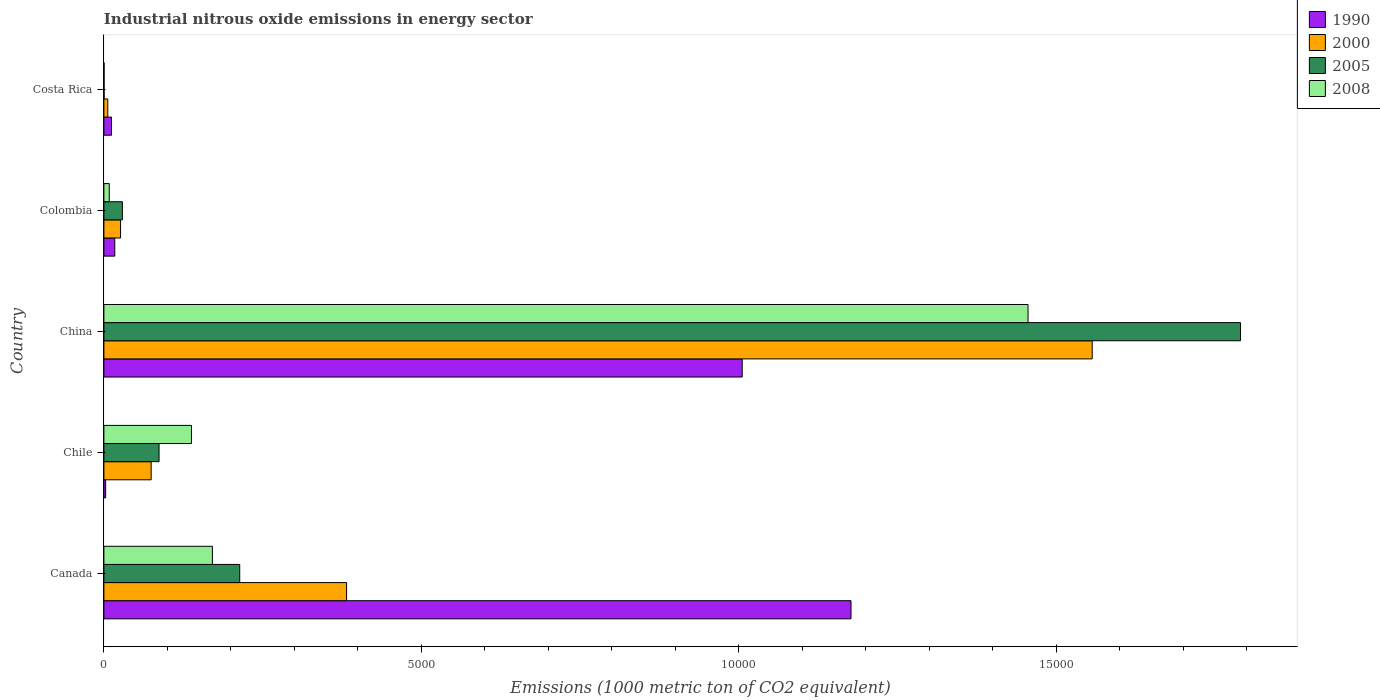How many groups of bars are there?
Make the answer very short. 5. Are the number of bars per tick equal to the number of legend labels?
Keep it short and to the point. Yes. Are the number of bars on each tick of the Y-axis equal?
Provide a succinct answer. Yes. How many bars are there on the 1st tick from the bottom?
Your response must be concise. 4. What is the label of the 3rd group of bars from the top?
Your answer should be compact. China. What is the amount of industrial nitrous oxide emitted in 2000 in Canada?
Ensure brevity in your answer.  3823.3. Across all countries, what is the maximum amount of industrial nitrous oxide emitted in 2008?
Offer a terse response. 1.46e+04. Across all countries, what is the minimum amount of industrial nitrous oxide emitted in 1990?
Provide a short and direct response. 27.9. What is the total amount of industrial nitrous oxide emitted in 2008 in the graph?
Your answer should be compact. 1.77e+04. What is the difference between the amount of industrial nitrous oxide emitted in 2008 in China and that in Costa Rica?
Your answer should be very brief. 1.46e+04. What is the difference between the amount of industrial nitrous oxide emitted in 2000 in Chile and the amount of industrial nitrous oxide emitted in 2005 in Canada?
Your answer should be compact. -1394.8. What is the average amount of industrial nitrous oxide emitted in 1990 per country?
Your answer should be very brief. 4429.12. What is the difference between the amount of industrial nitrous oxide emitted in 2000 and amount of industrial nitrous oxide emitted in 2008 in China?
Offer a very short reply. 1010.8. In how many countries, is the amount of industrial nitrous oxide emitted in 2005 greater than 3000 1000 metric ton?
Make the answer very short. 1. What is the ratio of the amount of industrial nitrous oxide emitted in 1990 in Canada to that in Costa Rica?
Give a very brief answer. 98.08. Is the amount of industrial nitrous oxide emitted in 2000 in Canada less than that in China?
Provide a succinct answer. Yes. Is the difference between the amount of industrial nitrous oxide emitted in 2000 in China and Colombia greater than the difference between the amount of industrial nitrous oxide emitted in 2008 in China and Colombia?
Offer a terse response. Yes. What is the difference between the highest and the second highest amount of industrial nitrous oxide emitted in 2005?
Offer a terse response. 1.58e+04. What is the difference between the highest and the lowest amount of industrial nitrous oxide emitted in 2008?
Keep it short and to the point. 1.46e+04. In how many countries, is the amount of industrial nitrous oxide emitted in 1990 greater than the average amount of industrial nitrous oxide emitted in 1990 taken over all countries?
Your response must be concise. 2. Is the sum of the amount of industrial nitrous oxide emitted in 2005 in Canada and China greater than the maximum amount of industrial nitrous oxide emitted in 2008 across all countries?
Ensure brevity in your answer.  Yes. Is it the case that in every country, the sum of the amount of industrial nitrous oxide emitted in 2005 and amount of industrial nitrous oxide emitted in 2008 is greater than the sum of amount of industrial nitrous oxide emitted in 1990 and amount of industrial nitrous oxide emitted in 2000?
Your answer should be very brief. No. What does the 4th bar from the top in Colombia represents?
Offer a very short reply. 1990. Is it the case that in every country, the sum of the amount of industrial nitrous oxide emitted in 2008 and amount of industrial nitrous oxide emitted in 1990 is greater than the amount of industrial nitrous oxide emitted in 2005?
Ensure brevity in your answer.  No. How many bars are there?
Provide a short and direct response. 20. How many countries are there in the graph?
Your answer should be very brief. 5. Are the values on the major ticks of X-axis written in scientific E-notation?
Your answer should be very brief. No. Does the graph contain any zero values?
Provide a succinct answer. No. Does the graph contain grids?
Provide a succinct answer. No. Where does the legend appear in the graph?
Provide a short and direct response. Top right. How many legend labels are there?
Provide a short and direct response. 4. How are the legend labels stacked?
Provide a short and direct response. Vertical. What is the title of the graph?
Provide a succinct answer. Industrial nitrous oxide emissions in energy sector. Does "1986" appear as one of the legend labels in the graph?
Your answer should be very brief. No. What is the label or title of the X-axis?
Your answer should be very brief. Emissions (1000 metric ton of CO2 equivalent). What is the Emissions (1000 metric ton of CO2 equivalent) in 1990 in Canada?
Your answer should be compact. 1.18e+04. What is the Emissions (1000 metric ton of CO2 equivalent) in 2000 in Canada?
Provide a short and direct response. 3823.3. What is the Emissions (1000 metric ton of CO2 equivalent) of 2005 in Canada?
Your response must be concise. 2139.7. What is the Emissions (1000 metric ton of CO2 equivalent) of 2008 in Canada?
Keep it short and to the point. 1709.6. What is the Emissions (1000 metric ton of CO2 equivalent) in 1990 in Chile?
Offer a terse response. 27.9. What is the Emissions (1000 metric ton of CO2 equivalent) of 2000 in Chile?
Offer a terse response. 744.9. What is the Emissions (1000 metric ton of CO2 equivalent) of 2005 in Chile?
Offer a very short reply. 868.8. What is the Emissions (1000 metric ton of CO2 equivalent) in 2008 in Chile?
Ensure brevity in your answer.  1379.7. What is the Emissions (1000 metric ton of CO2 equivalent) in 1990 in China?
Your answer should be compact. 1.01e+04. What is the Emissions (1000 metric ton of CO2 equivalent) in 2000 in China?
Offer a terse response. 1.56e+04. What is the Emissions (1000 metric ton of CO2 equivalent) in 2005 in China?
Offer a terse response. 1.79e+04. What is the Emissions (1000 metric ton of CO2 equivalent) of 2008 in China?
Offer a very short reply. 1.46e+04. What is the Emissions (1000 metric ton of CO2 equivalent) of 1990 in Colombia?
Ensure brevity in your answer.  171.6. What is the Emissions (1000 metric ton of CO2 equivalent) of 2000 in Colombia?
Provide a short and direct response. 262.3. What is the Emissions (1000 metric ton of CO2 equivalent) in 2005 in Colombia?
Ensure brevity in your answer.  291.3. What is the Emissions (1000 metric ton of CO2 equivalent) of 2008 in Colombia?
Ensure brevity in your answer.  84.7. What is the Emissions (1000 metric ton of CO2 equivalent) in 1990 in Costa Rica?
Ensure brevity in your answer.  120. What is the Emissions (1000 metric ton of CO2 equivalent) of 2000 in Costa Rica?
Offer a terse response. 61.4. What is the Emissions (1000 metric ton of CO2 equivalent) in 2008 in Costa Rica?
Provide a succinct answer. 3.1. Across all countries, what is the maximum Emissions (1000 metric ton of CO2 equivalent) in 1990?
Your answer should be compact. 1.18e+04. Across all countries, what is the maximum Emissions (1000 metric ton of CO2 equivalent) in 2000?
Provide a succinct answer. 1.56e+04. Across all countries, what is the maximum Emissions (1000 metric ton of CO2 equivalent) in 2005?
Offer a very short reply. 1.79e+04. Across all countries, what is the maximum Emissions (1000 metric ton of CO2 equivalent) of 2008?
Your answer should be compact. 1.46e+04. Across all countries, what is the minimum Emissions (1000 metric ton of CO2 equivalent) in 1990?
Ensure brevity in your answer.  27.9. Across all countries, what is the minimum Emissions (1000 metric ton of CO2 equivalent) of 2000?
Keep it short and to the point. 61.4. What is the total Emissions (1000 metric ton of CO2 equivalent) of 1990 in the graph?
Keep it short and to the point. 2.21e+04. What is the total Emissions (1000 metric ton of CO2 equivalent) of 2000 in the graph?
Offer a very short reply. 2.05e+04. What is the total Emissions (1000 metric ton of CO2 equivalent) of 2005 in the graph?
Your response must be concise. 2.12e+04. What is the total Emissions (1000 metric ton of CO2 equivalent) in 2008 in the graph?
Your response must be concise. 1.77e+04. What is the difference between the Emissions (1000 metric ton of CO2 equivalent) in 1990 in Canada and that in Chile?
Offer a terse response. 1.17e+04. What is the difference between the Emissions (1000 metric ton of CO2 equivalent) of 2000 in Canada and that in Chile?
Make the answer very short. 3078.4. What is the difference between the Emissions (1000 metric ton of CO2 equivalent) in 2005 in Canada and that in Chile?
Provide a succinct answer. 1270.9. What is the difference between the Emissions (1000 metric ton of CO2 equivalent) of 2008 in Canada and that in Chile?
Offer a very short reply. 329.9. What is the difference between the Emissions (1000 metric ton of CO2 equivalent) of 1990 in Canada and that in China?
Offer a terse response. 1713.9. What is the difference between the Emissions (1000 metric ton of CO2 equivalent) in 2000 in Canada and that in China?
Ensure brevity in your answer.  -1.17e+04. What is the difference between the Emissions (1000 metric ton of CO2 equivalent) of 2005 in Canada and that in China?
Make the answer very short. -1.58e+04. What is the difference between the Emissions (1000 metric ton of CO2 equivalent) of 2008 in Canada and that in China?
Your answer should be very brief. -1.28e+04. What is the difference between the Emissions (1000 metric ton of CO2 equivalent) in 1990 in Canada and that in Colombia?
Provide a short and direct response. 1.16e+04. What is the difference between the Emissions (1000 metric ton of CO2 equivalent) of 2000 in Canada and that in Colombia?
Ensure brevity in your answer.  3561. What is the difference between the Emissions (1000 metric ton of CO2 equivalent) in 2005 in Canada and that in Colombia?
Give a very brief answer. 1848.4. What is the difference between the Emissions (1000 metric ton of CO2 equivalent) in 2008 in Canada and that in Colombia?
Keep it short and to the point. 1624.9. What is the difference between the Emissions (1000 metric ton of CO2 equivalent) of 1990 in Canada and that in Costa Rica?
Provide a short and direct response. 1.16e+04. What is the difference between the Emissions (1000 metric ton of CO2 equivalent) of 2000 in Canada and that in Costa Rica?
Ensure brevity in your answer.  3761.9. What is the difference between the Emissions (1000 metric ton of CO2 equivalent) in 2005 in Canada and that in Costa Rica?
Provide a succinct answer. 2136.6. What is the difference between the Emissions (1000 metric ton of CO2 equivalent) of 2008 in Canada and that in Costa Rica?
Provide a succinct answer. 1706.5. What is the difference between the Emissions (1000 metric ton of CO2 equivalent) in 1990 in Chile and that in China?
Your answer should be compact. -1.00e+04. What is the difference between the Emissions (1000 metric ton of CO2 equivalent) of 2000 in Chile and that in China?
Give a very brief answer. -1.48e+04. What is the difference between the Emissions (1000 metric ton of CO2 equivalent) in 2005 in Chile and that in China?
Your answer should be very brief. -1.70e+04. What is the difference between the Emissions (1000 metric ton of CO2 equivalent) of 2008 in Chile and that in China?
Your response must be concise. -1.32e+04. What is the difference between the Emissions (1000 metric ton of CO2 equivalent) of 1990 in Chile and that in Colombia?
Ensure brevity in your answer.  -143.7. What is the difference between the Emissions (1000 metric ton of CO2 equivalent) in 2000 in Chile and that in Colombia?
Provide a succinct answer. 482.6. What is the difference between the Emissions (1000 metric ton of CO2 equivalent) of 2005 in Chile and that in Colombia?
Provide a short and direct response. 577.5. What is the difference between the Emissions (1000 metric ton of CO2 equivalent) in 2008 in Chile and that in Colombia?
Provide a short and direct response. 1295. What is the difference between the Emissions (1000 metric ton of CO2 equivalent) in 1990 in Chile and that in Costa Rica?
Provide a short and direct response. -92.1. What is the difference between the Emissions (1000 metric ton of CO2 equivalent) of 2000 in Chile and that in Costa Rica?
Offer a very short reply. 683.5. What is the difference between the Emissions (1000 metric ton of CO2 equivalent) in 2005 in Chile and that in Costa Rica?
Make the answer very short. 865.7. What is the difference between the Emissions (1000 metric ton of CO2 equivalent) of 2008 in Chile and that in Costa Rica?
Provide a succinct answer. 1376.6. What is the difference between the Emissions (1000 metric ton of CO2 equivalent) in 1990 in China and that in Colombia?
Provide a succinct answer. 9884.5. What is the difference between the Emissions (1000 metric ton of CO2 equivalent) in 2000 in China and that in Colombia?
Your answer should be very brief. 1.53e+04. What is the difference between the Emissions (1000 metric ton of CO2 equivalent) of 2005 in China and that in Colombia?
Provide a succinct answer. 1.76e+04. What is the difference between the Emissions (1000 metric ton of CO2 equivalent) of 2008 in China and that in Colombia?
Provide a succinct answer. 1.45e+04. What is the difference between the Emissions (1000 metric ton of CO2 equivalent) in 1990 in China and that in Costa Rica?
Your response must be concise. 9936.1. What is the difference between the Emissions (1000 metric ton of CO2 equivalent) of 2000 in China and that in Costa Rica?
Provide a succinct answer. 1.55e+04. What is the difference between the Emissions (1000 metric ton of CO2 equivalent) of 2005 in China and that in Costa Rica?
Provide a short and direct response. 1.79e+04. What is the difference between the Emissions (1000 metric ton of CO2 equivalent) of 2008 in China and that in Costa Rica?
Give a very brief answer. 1.46e+04. What is the difference between the Emissions (1000 metric ton of CO2 equivalent) of 1990 in Colombia and that in Costa Rica?
Ensure brevity in your answer.  51.6. What is the difference between the Emissions (1000 metric ton of CO2 equivalent) in 2000 in Colombia and that in Costa Rica?
Provide a short and direct response. 200.9. What is the difference between the Emissions (1000 metric ton of CO2 equivalent) of 2005 in Colombia and that in Costa Rica?
Give a very brief answer. 288.2. What is the difference between the Emissions (1000 metric ton of CO2 equivalent) of 2008 in Colombia and that in Costa Rica?
Offer a very short reply. 81.6. What is the difference between the Emissions (1000 metric ton of CO2 equivalent) of 1990 in Canada and the Emissions (1000 metric ton of CO2 equivalent) of 2000 in Chile?
Give a very brief answer. 1.10e+04. What is the difference between the Emissions (1000 metric ton of CO2 equivalent) in 1990 in Canada and the Emissions (1000 metric ton of CO2 equivalent) in 2005 in Chile?
Offer a very short reply. 1.09e+04. What is the difference between the Emissions (1000 metric ton of CO2 equivalent) in 1990 in Canada and the Emissions (1000 metric ton of CO2 equivalent) in 2008 in Chile?
Your response must be concise. 1.04e+04. What is the difference between the Emissions (1000 metric ton of CO2 equivalent) in 2000 in Canada and the Emissions (1000 metric ton of CO2 equivalent) in 2005 in Chile?
Make the answer very short. 2954.5. What is the difference between the Emissions (1000 metric ton of CO2 equivalent) of 2000 in Canada and the Emissions (1000 metric ton of CO2 equivalent) of 2008 in Chile?
Offer a very short reply. 2443.6. What is the difference between the Emissions (1000 metric ton of CO2 equivalent) in 2005 in Canada and the Emissions (1000 metric ton of CO2 equivalent) in 2008 in Chile?
Offer a very short reply. 760. What is the difference between the Emissions (1000 metric ton of CO2 equivalent) of 1990 in Canada and the Emissions (1000 metric ton of CO2 equivalent) of 2000 in China?
Ensure brevity in your answer.  -3799.7. What is the difference between the Emissions (1000 metric ton of CO2 equivalent) of 1990 in Canada and the Emissions (1000 metric ton of CO2 equivalent) of 2005 in China?
Ensure brevity in your answer.  -6136.4. What is the difference between the Emissions (1000 metric ton of CO2 equivalent) in 1990 in Canada and the Emissions (1000 metric ton of CO2 equivalent) in 2008 in China?
Ensure brevity in your answer.  -2788.9. What is the difference between the Emissions (1000 metric ton of CO2 equivalent) of 2000 in Canada and the Emissions (1000 metric ton of CO2 equivalent) of 2005 in China?
Ensure brevity in your answer.  -1.41e+04. What is the difference between the Emissions (1000 metric ton of CO2 equivalent) of 2000 in Canada and the Emissions (1000 metric ton of CO2 equivalent) of 2008 in China?
Provide a short and direct response. -1.07e+04. What is the difference between the Emissions (1000 metric ton of CO2 equivalent) in 2005 in Canada and the Emissions (1000 metric ton of CO2 equivalent) in 2008 in China?
Give a very brief answer. -1.24e+04. What is the difference between the Emissions (1000 metric ton of CO2 equivalent) of 1990 in Canada and the Emissions (1000 metric ton of CO2 equivalent) of 2000 in Colombia?
Keep it short and to the point. 1.15e+04. What is the difference between the Emissions (1000 metric ton of CO2 equivalent) in 1990 in Canada and the Emissions (1000 metric ton of CO2 equivalent) in 2005 in Colombia?
Make the answer very short. 1.15e+04. What is the difference between the Emissions (1000 metric ton of CO2 equivalent) in 1990 in Canada and the Emissions (1000 metric ton of CO2 equivalent) in 2008 in Colombia?
Provide a succinct answer. 1.17e+04. What is the difference between the Emissions (1000 metric ton of CO2 equivalent) of 2000 in Canada and the Emissions (1000 metric ton of CO2 equivalent) of 2005 in Colombia?
Your answer should be compact. 3532. What is the difference between the Emissions (1000 metric ton of CO2 equivalent) in 2000 in Canada and the Emissions (1000 metric ton of CO2 equivalent) in 2008 in Colombia?
Offer a terse response. 3738.6. What is the difference between the Emissions (1000 metric ton of CO2 equivalent) of 2005 in Canada and the Emissions (1000 metric ton of CO2 equivalent) of 2008 in Colombia?
Offer a terse response. 2055. What is the difference between the Emissions (1000 metric ton of CO2 equivalent) of 1990 in Canada and the Emissions (1000 metric ton of CO2 equivalent) of 2000 in Costa Rica?
Make the answer very short. 1.17e+04. What is the difference between the Emissions (1000 metric ton of CO2 equivalent) of 1990 in Canada and the Emissions (1000 metric ton of CO2 equivalent) of 2005 in Costa Rica?
Provide a succinct answer. 1.18e+04. What is the difference between the Emissions (1000 metric ton of CO2 equivalent) of 1990 in Canada and the Emissions (1000 metric ton of CO2 equivalent) of 2008 in Costa Rica?
Give a very brief answer. 1.18e+04. What is the difference between the Emissions (1000 metric ton of CO2 equivalent) in 2000 in Canada and the Emissions (1000 metric ton of CO2 equivalent) in 2005 in Costa Rica?
Ensure brevity in your answer.  3820.2. What is the difference between the Emissions (1000 metric ton of CO2 equivalent) of 2000 in Canada and the Emissions (1000 metric ton of CO2 equivalent) of 2008 in Costa Rica?
Your answer should be very brief. 3820.2. What is the difference between the Emissions (1000 metric ton of CO2 equivalent) in 2005 in Canada and the Emissions (1000 metric ton of CO2 equivalent) in 2008 in Costa Rica?
Your answer should be very brief. 2136.6. What is the difference between the Emissions (1000 metric ton of CO2 equivalent) in 1990 in Chile and the Emissions (1000 metric ton of CO2 equivalent) in 2000 in China?
Your answer should be compact. -1.55e+04. What is the difference between the Emissions (1000 metric ton of CO2 equivalent) in 1990 in Chile and the Emissions (1000 metric ton of CO2 equivalent) in 2005 in China?
Offer a very short reply. -1.79e+04. What is the difference between the Emissions (1000 metric ton of CO2 equivalent) of 1990 in Chile and the Emissions (1000 metric ton of CO2 equivalent) of 2008 in China?
Offer a very short reply. -1.45e+04. What is the difference between the Emissions (1000 metric ton of CO2 equivalent) in 2000 in Chile and the Emissions (1000 metric ton of CO2 equivalent) in 2005 in China?
Ensure brevity in your answer.  -1.72e+04. What is the difference between the Emissions (1000 metric ton of CO2 equivalent) of 2000 in Chile and the Emissions (1000 metric ton of CO2 equivalent) of 2008 in China?
Make the answer very short. -1.38e+04. What is the difference between the Emissions (1000 metric ton of CO2 equivalent) of 2005 in Chile and the Emissions (1000 metric ton of CO2 equivalent) of 2008 in China?
Your answer should be compact. -1.37e+04. What is the difference between the Emissions (1000 metric ton of CO2 equivalent) of 1990 in Chile and the Emissions (1000 metric ton of CO2 equivalent) of 2000 in Colombia?
Your answer should be very brief. -234.4. What is the difference between the Emissions (1000 metric ton of CO2 equivalent) of 1990 in Chile and the Emissions (1000 metric ton of CO2 equivalent) of 2005 in Colombia?
Your response must be concise. -263.4. What is the difference between the Emissions (1000 metric ton of CO2 equivalent) in 1990 in Chile and the Emissions (1000 metric ton of CO2 equivalent) in 2008 in Colombia?
Offer a very short reply. -56.8. What is the difference between the Emissions (1000 metric ton of CO2 equivalent) in 2000 in Chile and the Emissions (1000 metric ton of CO2 equivalent) in 2005 in Colombia?
Your response must be concise. 453.6. What is the difference between the Emissions (1000 metric ton of CO2 equivalent) in 2000 in Chile and the Emissions (1000 metric ton of CO2 equivalent) in 2008 in Colombia?
Keep it short and to the point. 660.2. What is the difference between the Emissions (1000 metric ton of CO2 equivalent) of 2005 in Chile and the Emissions (1000 metric ton of CO2 equivalent) of 2008 in Colombia?
Give a very brief answer. 784.1. What is the difference between the Emissions (1000 metric ton of CO2 equivalent) of 1990 in Chile and the Emissions (1000 metric ton of CO2 equivalent) of 2000 in Costa Rica?
Your response must be concise. -33.5. What is the difference between the Emissions (1000 metric ton of CO2 equivalent) of 1990 in Chile and the Emissions (1000 metric ton of CO2 equivalent) of 2005 in Costa Rica?
Provide a succinct answer. 24.8. What is the difference between the Emissions (1000 metric ton of CO2 equivalent) of 1990 in Chile and the Emissions (1000 metric ton of CO2 equivalent) of 2008 in Costa Rica?
Keep it short and to the point. 24.8. What is the difference between the Emissions (1000 metric ton of CO2 equivalent) of 2000 in Chile and the Emissions (1000 metric ton of CO2 equivalent) of 2005 in Costa Rica?
Offer a very short reply. 741.8. What is the difference between the Emissions (1000 metric ton of CO2 equivalent) in 2000 in Chile and the Emissions (1000 metric ton of CO2 equivalent) in 2008 in Costa Rica?
Your response must be concise. 741.8. What is the difference between the Emissions (1000 metric ton of CO2 equivalent) of 2005 in Chile and the Emissions (1000 metric ton of CO2 equivalent) of 2008 in Costa Rica?
Your response must be concise. 865.7. What is the difference between the Emissions (1000 metric ton of CO2 equivalent) of 1990 in China and the Emissions (1000 metric ton of CO2 equivalent) of 2000 in Colombia?
Offer a terse response. 9793.8. What is the difference between the Emissions (1000 metric ton of CO2 equivalent) of 1990 in China and the Emissions (1000 metric ton of CO2 equivalent) of 2005 in Colombia?
Offer a terse response. 9764.8. What is the difference between the Emissions (1000 metric ton of CO2 equivalent) in 1990 in China and the Emissions (1000 metric ton of CO2 equivalent) in 2008 in Colombia?
Give a very brief answer. 9971.4. What is the difference between the Emissions (1000 metric ton of CO2 equivalent) in 2000 in China and the Emissions (1000 metric ton of CO2 equivalent) in 2005 in Colombia?
Your answer should be compact. 1.53e+04. What is the difference between the Emissions (1000 metric ton of CO2 equivalent) in 2000 in China and the Emissions (1000 metric ton of CO2 equivalent) in 2008 in Colombia?
Your answer should be compact. 1.55e+04. What is the difference between the Emissions (1000 metric ton of CO2 equivalent) of 2005 in China and the Emissions (1000 metric ton of CO2 equivalent) of 2008 in Colombia?
Offer a very short reply. 1.78e+04. What is the difference between the Emissions (1000 metric ton of CO2 equivalent) of 1990 in China and the Emissions (1000 metric ton of CO2 equivalent) of 2000 in Costa Rica?
Give a very brief answer. 9994.7. What is the difference between the Emissions (1000 metric ton of CO2 equivalent) in 1990 in China and the Emissions (1000 metric ton of CO2 equivalent) in 2005 in Costa Rica?
Provide a succinct answer. 1.01e+04. What is the difference between the Emissions (1000 metric ton of CO2 equivalent) of 1990 in China and the Emissions (1000 metric ton of CO2 equivalent) of 2008 in Costa Rica?
Offer a very short reply. 1.01e+04. What is the difference between the Emissions (1000 metric ton of CO2 equivalent) in 2000 in China and the Emissions (1000 metric ton of CO2 equivalent) in 2005 in Costa Rica?
Your response must be concise. 1.56e+04. What is the difference between the Emissions (1000 metric ton of CO2 equivalent) of 2000 in China and the Emissions (1000 metric ton of CO2 equivalent) of 2008 in Costa Rica?
Make the answer very short. 1.56e+04. What is the difference between the Emissions (1000 metric ton of CO2 equivalent) in 2005 in China and the Emissions (1000 metric ton of CO2 equivalent) in 2008 in Costa Rica?
Provide a short and direct response. 1.79e+04. What is the difference between the Emissions (1000 metric ton of CO2 equivalent) in 1990 in Colombia and the Emissions (1000 metric ton of CO2 equivalent) in 2000 in Costa Rica?
Provide a succinct answer. 110.2. What is the difference between the Emissions (1000 metric ton of CO2 equivalent) of 1990 in Colombia and the Emissions (1000 metric ton of CO2 equivalent) of 2005 in Costa Rica?
Offer a terse response. 168.5. What is the difference between the Emissions (1000 metric ton of CO2 equivalent) in 1990 in Colombia and the Emissions (1000 metric ton of CO2 equivalent) in 2008 in Costa Rica?
Offer a very short reply. 168.5. What is the difference between the Emissions (1000 metric ton of CO2 equivalent) of 2000 in Colombia and the Emissions (1000 metric ton of CO2 equivalent) of 2005 in Costa Rica?
Keep it short and to the point. 259.2. What is the difference between the Emissions (1000 metric ton of CO2 equivalent) in 2000 in Colombia and the Emissions (1000 metric ton of CO2 equivalent) in 2008 in Costa Rica?
Keep it short and to the point. 259.2. What is the difference between the Emissions (1000 metric ton of CO2 equivalent) in 2005 in Colombia and the Emissions (1000 metric ton of CO2 equivalent) in 2008 in Costa Rica?
Offer a very short reply. 288.2. What is the average Emissions (1000 metric ton of CO2 equivalent) in 1990 per country?
Your answer should be compact. 4429.12. What is the average Emissions (1000 metric ton of CO2 equivalent) of 2000 per country?
Your answer should be compact. 4092.32. What is the average Emissions (1000 metric ton of CO2 equivalent) in 2005 per country?
Make the answer very short. 4241.86. What is the average Emissions (1000 metric ton of CO2 equivalent) in 2008 per country?
Ensure brevity in your answer.  3547.2. What is the difference between the Emissions (1000 metric ton of CO2 equivalent) of 1990 and Emissions (1000 metric ton of CO2 equivalent) of 2000 in Canada?
Provide a short and direct response. 7946.7. What is the difference between the Emissions (1000 metric ton of CO2 equivalent) in 1990 and Emissions (1000 metric ton of CO2 equivalent) in 2005 in Canada?
Keep it short and to the point. 9630.3. What is the difference between the Emissions (1000 metric ton of CO2 equivalent) in 1990 and Emissions (1000 metric ton of CO2 equivalent) in 2008 in Canada?
Make the answer very short. 1.01e+04. What is the difference between the Emissions (1000 metric ton of CO2 equivalent) of 2000 and Emissions (1000 metric ton of CO2 equivalent) of 2005 in Canada?
Provide a succinct answer. 1683.6. What is the difference between the Emissions (1000 metric ton of CO2 equivalent) in 2000 and Emissions (1000 metric ton of CO2 equivalent) in 2008 in Canada?
Ensure brevity in your answer.  2113.7. What is the difference between the Emissions (1000 metric ton of CO2 equivalent) of 2005 and Emissions (1000 metric ton of CO2 equivalent) of 2008 in Canada?
Offer a very short reply. 430.1. What is the difference between the Emissions (1000 metric ton of CO2 equivalent) of 1990 and Emissions (1000 metric ton of CO2 equivalent) of 2000 in Chile?
Keep it short and to the point. -717. What is the difference between the Emissions (1000 metric ton of CO2 equivalent) of 1990 and Emissions (1000 metric ton of CO2 equivalent) of 2005 in Chile?
Your response must be concise. -840.9. What is the difference between the Emissions (1000 metric ton of CO2 equivalent) in 1990 and Emissions (1000 metric ton of CO2 equivalent) in 2008 in Chile?
Make the answer very short. -1351.8. What is the difference between the Emissions (1000 metric ton of CO2 equivalent) in 2000 and Emissions (1000 metric ton of CO2 equivalent) in 2005 in Chile?
Offer a very short reply. -123.9. What is the difference between the Emissions (1000 metric ton of CO2 equivalent) in 2000 and Emissions (1000 metric ton of CO2 equivalent) in 2008 in Chile?
Make the answer very short. -634.8. What is the difference between the Emissions (1000 metric ton of CO2 equivalent) of 2005 and Emissions (1000 metric ton of CO2 equivalent) of 2008 in Chile?
Your answer should be very brief. -510.9. What is the difference between the Emissions (1000 metric ton of CO2 equivalent) in 1990 and Emissions (1000 metric ton of CO2 equivalent) in 2000 in China?
Your answer should be compact. -5513.6. What is the difference between the Emissions (1000 metric ton of CO2 equivalent) in 1990 and Emissions (1000 metric ton of CO2 equivalent) in 2005 in China?
Give a very brief answer. -7850.3. What is the difference between the Emissions (1000 metric ton of CO2 equivalent) of 1990 and Emissions (1000 metric ton of CO2 equivalent) of 2008 in China?
Your response must be concise. -4502.8. What is the difference between the Emissions (1000 metric ton of CO2 equivalent) of 2000 and Emissions (1000 metric ton of CO2 equivalent) of 2005 in China?
Ensure brevity in your answer.  -2336.7. What is the difference between the Emissions (1000 metric ton of CO2 equivalent) in 2000 and Emissions (1000 metric ton of CO2 equivalent) in 2008 in China?
Keep it short and to the point. 1010.8. What is the difference between the Emissions (1000 metric ton of CO2 equivalent) in 2005 and Emissions (1000 metric ton of CO2 equivalent) in 2008 in China?
Ensure brevity in your answer.  3347.5. What is the difference between the Emissions (1000 metric ton of CO2 equivalent) of 1990 and Emissions (1000 metric ton of CO2 equivalent) of 2000 in Colombia?
Keep it short and to the point. -90.7. What is the difference between the Emissions (1000 metric ton of CO2 equivalent) in 1990 and Emissions (1000 metric ton of CO2 equivalent) in 2005 in Colombia?
Offer a terse response. -119.7. What is the difference between the Emissions (1000 metric ton of CO2 equivalent) of 1990 and Emissions (1000 metric ton of CO2 equivalent) of 2008 in Colombia?
Offer a terse response. 86.9. What is the difference between the Emissions (1000 metric ton of CO2 equivalent) in 2000 and Emissions (1000 metric ton of CO2 equivalent) in 2005 in Colombia?
Ensure brevity in your answer.  -29. What is the difference between the Emissions (1000 metric ton of CO2 equivalent) of 2000 and Emissions (1000 metric ton of CO2 equivalent) of 2008 in Colombia?
Offer a very short reply. 177.6. What is the difference between the Emissions (1000 metric ton of CO2 equivalent) in 2005 and Emissions (1000 metric ton of CO2 equivalent) in 2008 in Colombia?
Make the answer very short. 206.6. What is the difference between the Emissions (1000 metric ton of CO2 equivalent) of 1990 and Emissions (1000 metric ton of CO2 equivalent) of 2000 in Costa Rica?
Your response must be concise. 58.6. What is the difference between the Emissions (1000 metric ton of CO2 equivalent) in 1990 and Emissions (1000 metric ton of CO2 equivalent) in 2005 in Costa Rica?
Your answer should be very brief. 116.9. What is the difference between the Emissions (1000 metric ton of CO2 equivalent) in 1990 and Emissions (1000 metric ton of CO2 equivalent) in 2008 in Costa Rica?
Your answer should be compact. 116.9. What is the difference between the Emissions (1000 metric ton of CO2 equivalent) in 2000 and Emissions (1000 metric ton of CO2 equivalent) in 2005 in Costa Rica?
Keep it short and to the point. 58.3. What is the difference between the Emissions (1000 metric ton of CO2 equivalent) of 2000 and Emissions (1000 metric ton of CO2 equivalent) of 2008 in Costa Rica?
Your answer should be compact. 58.3. What is the difference between the Emissions (1000 metric ton of CO2 equivalent) in 2005 and Emissions (1000 metric ton of CO2 equivalent) in 2008 in Costa Rica?
Provide a short and direct response. 0. What is the ratio of the Emissions (1000 metric ton of CO2 equivalent) of 1990 in Canada to that in Chile?
Keep it short and to the point. 421.86. What is the ratio of the Emissions (1000 metric ton of CO2 equivalent) in 2000 in Canada to that in Chile?
Offer a terse response. 5.13. What is the ratio of the Emissions (1000 metric ton of CO2 equivalent) of 2005 in Canada to that in Chile?
Provide a succinct answer. 2.46. What is the ratio of the Emissions (1000 metric ton of CO2 equivalent) of 2008 in Canada to that in Chile?
Provide a short and direct response. 1.24. What is the ratio of the Emissions (1000 metric ton of CO2 equivalent) of 1990 in Canada to that in China?
Your answer should be very brief. 1.17. What is the ratio of the Emissions (1000 metric ton of CO2 equivalent) of 2000 in Canada to that in China?
Offer a terse response. 0.25. What is the ratio of the Emissions (1000 metric ton of CO2 equivalent) of 2005 in Canada to that in China?
Provide a short and direct response. 0.12. What is the ratio of the Emissions (1000 metric ton of CO2 equivalent) of 2008 in Canada to that in China?
Make the answer very short. 0.12. What is the ratio of the Emissions (1000 metric ton of CO2 equivalent) of 1990 in Canada to that in Colombia?
Give a very brief answer. 68.59. What is the ratio of the Emissions (1000 metric ton of CO2 equivalent) of 2000 in Canada to that in Colombia?
Your answer should be very brief. 14.58. What is the ratio of the Emissions (1000 metric ton of CO2 equivalent) of 2005 in Canada to that in Colombia?
Provide a short and direct response. 7.35. What is the ratio of the Emissions (1000 metric ton of CO2 equivalent) in 2008 in Canada to that in Colombia?
Ensure brevity in your answer.  20.18. What is the ratio of the Emissions (1000 metric ton of CO2 equivalent) in 1990 in Canada to that in Costa Rica?
Your response must be concise. 98.08. What is the ratio of the Emissions (1000 metric ton of CO2 equivalent) in 2000 in Canada to that in Costa Rica?
Make the answer very short. 62.27. What is the ratio of the Emissions (1000 metric ton of CO2 equivalent) of 2005 in Canada to that in Costa Rica?
Provide a succinct answer. 690.23. What is the ratio of the Emissions (1000 metric ton of CO2 equivalent) of 2008 in Canada to that in Costa Rica?
Your response must be concise. 551.48. What is the ratio of the Emissions (1000 metric ton of CO2 equivalent) in 1990 in Chile to that in China?
Provide a short and direct response. 0. What is the ratio of the Emissions (1000 metric ton of CO2 equivalent) in 2000 in Chile to that in China?
Your answer should be compact. 0.05. What is the ratio of the Emissions (1000 metric ton of CO2 equivalent) in 2005 in Chile to that in China?
Provide a succinct answer. 0.05. What is the ratio of the Emissions (1000 metric ton of CO2 equivalent) in 2008 in Chile to that in China?
Make the answer very short. 0.09. What is the ratio of the Emissions (1000 metric ton of CO2 equivalent) in 1990 in Chile to that in Colombia?
Provide a succinct answer. 0.16. What is the ratio of the Emissions (1000 metric ton of CO2 equivalent) in 2000 in Chile to that in Colombia?
Provide a short and direct response. 2.84. What is the ratio of the Emissions (1000 metric ton of CO2 equivalent) in 2005 in Chile to that in Colombia?
Provide a short and direct response. 2.98. What is the ratio of the Emissions (1000 metric ton of CO2 equivalent) in 2008 in Chile to that in Colombia?
Offer a very short reply. 16.29. What is the ratio of the Emissions (1000 metric ton of CO2 equivalent) in 1990 in Chile to that in Costa Rica?
Your answer should be very brief. 0.23. What is the ratio of the Emissions (1000 metric ton of CO2 equivalent) of 2000 in Chile to that in Costa Rica?
Keep it short and to the point. 12.13. What is the ratio of the Emissions (1000 metric ton of CO2 equivalent) in 2005 in Chile to that in Costa Rica?
Provide a short and direct response. 280.26. What is the ratio of the Emissions (1000 metric ton of CO2 equivalent) of 2008 in Chile to that in Costa Rica?
Provide a succinct answer. 445.06. What is the ratio of the Emissions (1000 metric ton of CO2 equivalent) in 1990 in China to that in Colombia?
Offer a very short reply. 58.6. What is the ratio of the Emissions (1000 metric ton of CO2 equivalent) of 2000 in China to that in Colombia?
Provide a short and direct response. 59.36. What is the ratio of the Emissions (1000 metric ton of CO2 equivalent) in 2005 in China to that in Colombia?
Offer a terse response. 61.47. What is the ratio of the Emissions (1000 metric ton of CO2 equivalent) in 2008 in China to that in Colombia?
Ensure brevity in your answer.  171.89. What is the ratio of the Emissions (1000 metric ton of CO2 equivalent) in 1990 in China to that in Costa Rica?
Offer a very short reply. 83.8. What is the ratio of the Emissions (1000 metric ton of CO2 equivalent) in 2000 in China to that in Costa Rica?
Keep it short and to the point. 253.58. What is the ratio of the Emissions (1000 metric ton of CO2 equivalent) of 2005 in China to that in Costa Rica?
Offer a terse response. 5776.26. What is the ratio of the Emissions (1000 metric ton of CO2 equivalent) of 2008 in China to that in Costa Rica?
Provide a succinct answer. 4696.42. What is the ratio of the Emissions (1000 metric ton of CO2 equivalent) in 1990 in Colombia to that in Costa Rica?
Offer a terse response. 1.43. What is the ratio of the Emissions (1000 metric ton of CO2 equivalent) of 2000 in Colombia to that in Costa Rica?
Your answer should be very brief. 4.27. What is the ratio of the Emissions (1000 metric ton of CO2 equivalent) in 2005 in Colombia to that in Costa Rica?
Make the answer very short. 93.97. What is the ratio of the Emissions (1000 metric ton of CO2 equivalent) in 2008 in Colombia to that in Costa Rica?
Offer a terse response. 27.32. What is the difference between the highest and the second highest Emissions (1000 metric ton of CO2 equivalent) of 1990?
Keep it short and to the point. 1713.9. What is the difference between the highest and the second highest Emissions (1000 metric ton of CO2 equivalent) of 2000?
Your answer should be compact. 1.17e+04. What is the difference between the highest and the second highest Emissions (1000 metric ton of CO2 equivalent) in 2005?
Ensure brevity in your answer.  1.58e+04. What is the difference between the highest and the second highest Emissions (1000 metric ton of CO2 equivalent) in 2008?
Keep it short and to the point. 1.28e+04. What is the difference between the highest and the lowest Emissions (1000 metric ton of CO2 equivalent) of 1990?
Offer a terse response. 1.17e+04. What is the difference between the highest and the lowest Emissions (1000 metric ton of CO2 equivalent) in 2000?
Offer a terse response. 1.55e+04. What is the difference between the highest and the lowest Emissions (1000 metric ton of CO2 equivalent) in 2005?
Provide a short and direct response. 1.79e+04. What is the difference between the highest and the lowest Emissions (1000 metric ton of CO2 equivalent) in 2008?
Offer a very short reply. 1.46e+04. 